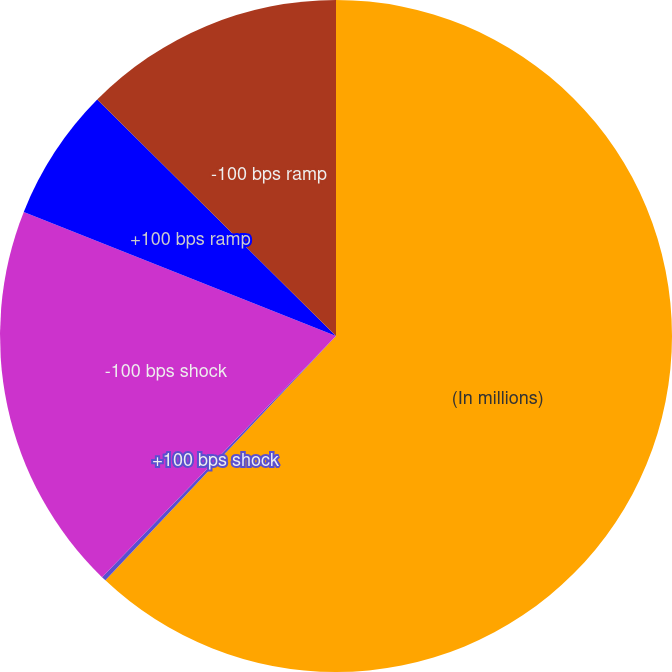Convert chart. <chart><loc_0><loc_0><loc_500><loc_500><pie_chart><fcel>(In millions)<fcel>+100 bps shock<fcel>-100 bps shock<fcel>+100 bps ramp<fcel>-100 bps ramp<nl><fcel>62.04%<fcel>0.22%<fcel>18.76%<fcel>6.4%<fcel>12.58%<nl></chart> 